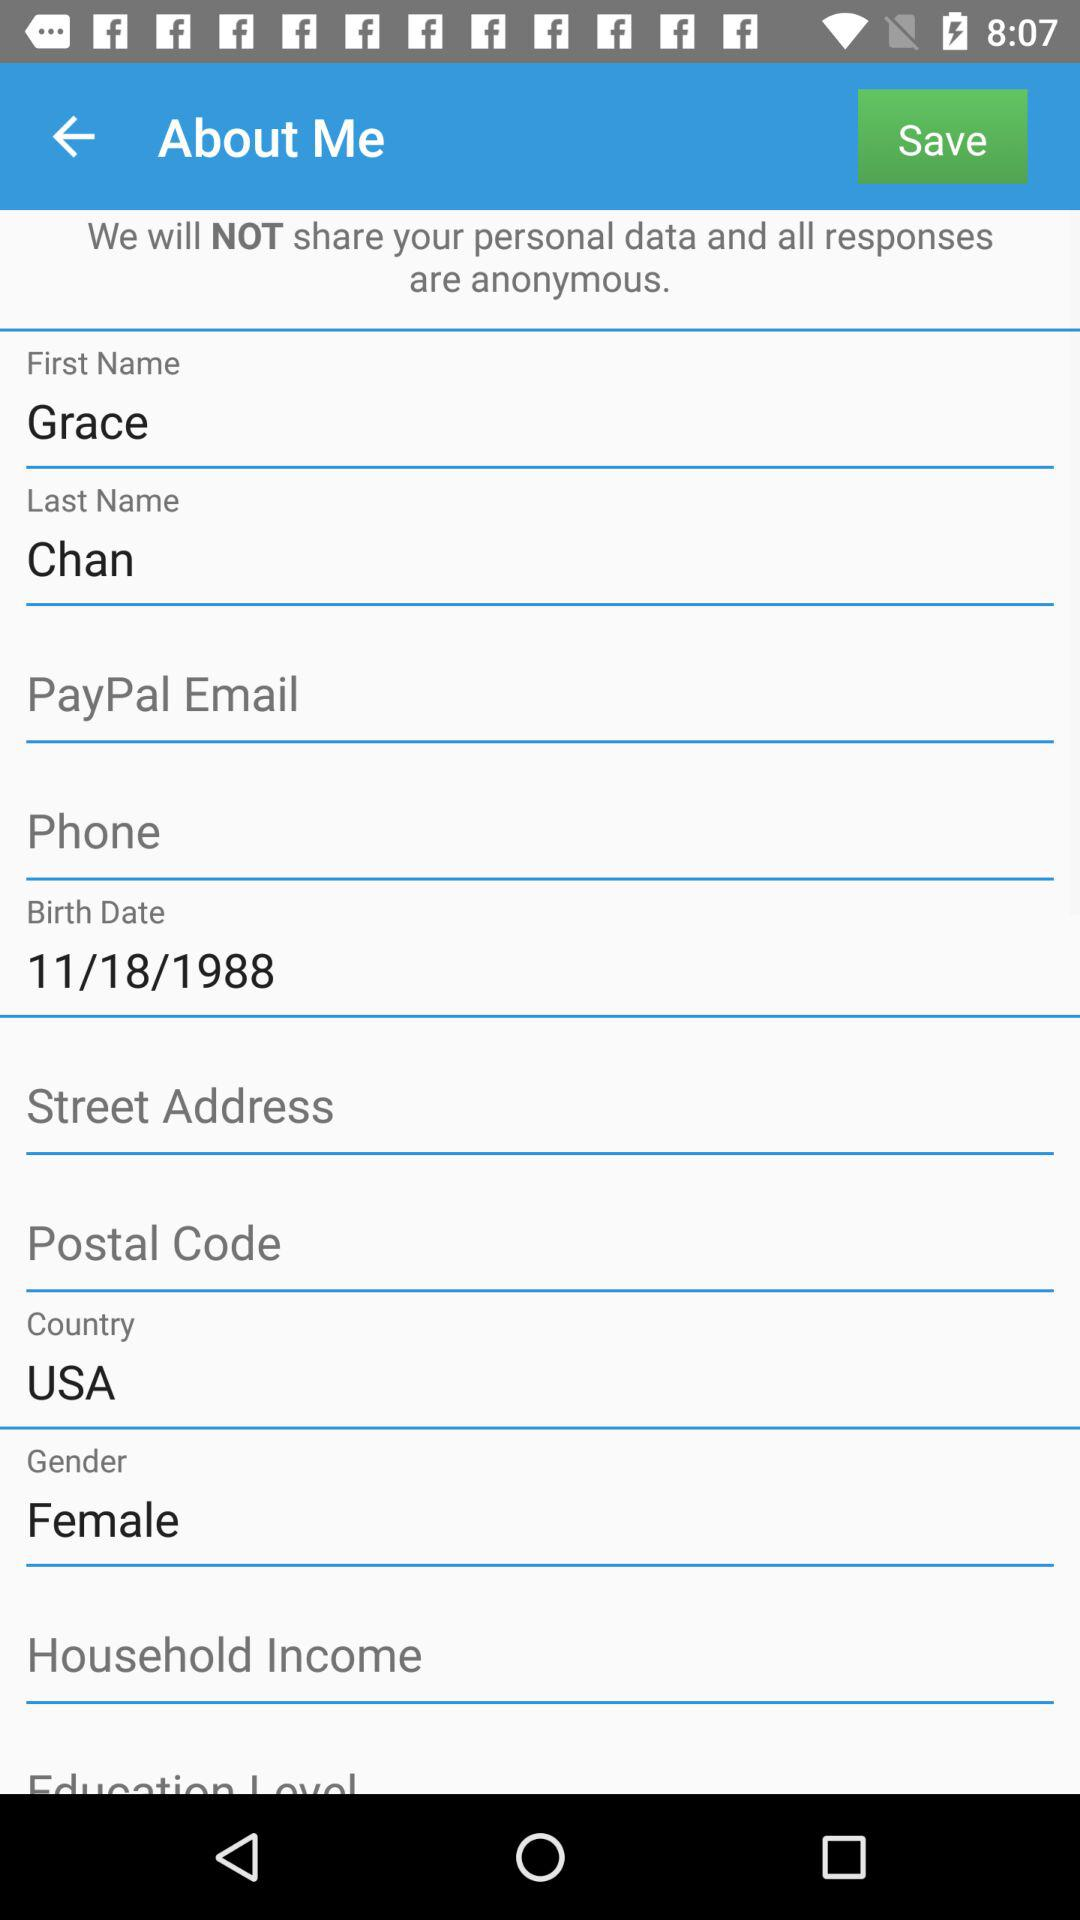What is the country name? The country name is the USA. 